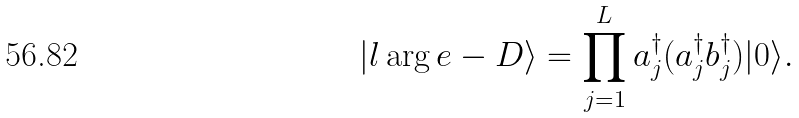<formula> <loc_0><loc_0><loc_500><loc_500>| l \arg e - D \rangle = \prod _ { j = 1 } ^ { L } a _ { j } ^ { \dagger } ( a _ { j } ^ { \dagger } b _ { j } ^ { \dagger } ) | 0 \rangle .</formula> 